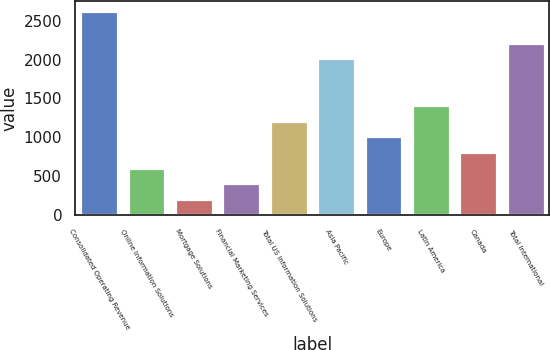<chart> <loc_0><loc_0><loc_500><loc_500><bar_chart><fcel>Consolidated Operating Revenue<fcel>Online Information Solutions<fcel>Mortgage Solutions<fcel>Financial Marketing Services<fcel>Total US Information Solutions<fcel>Asia Pacific<fcel>Europe<fcel>Latin America<fcel>Canada<fcel>Total International<nl><fcel>2621.44<fcel>606.64<fcel>203.68<fcel>405.16<fcel>1211.08<fcel>2017<fcel>1009.6<fcel>1412.56<fcel>808.12<fcel>2218.48<nl></chart> 